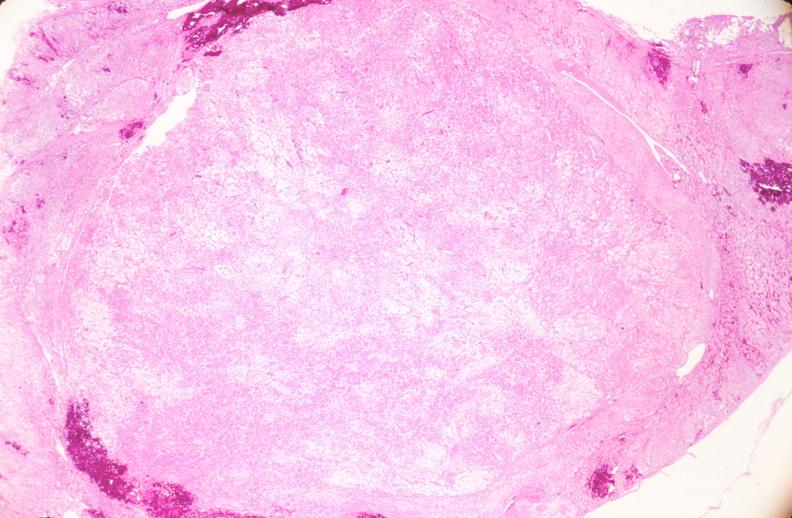does this image show uterus, leiomyoma?
Answer the question using a single word or phrase. Yes 